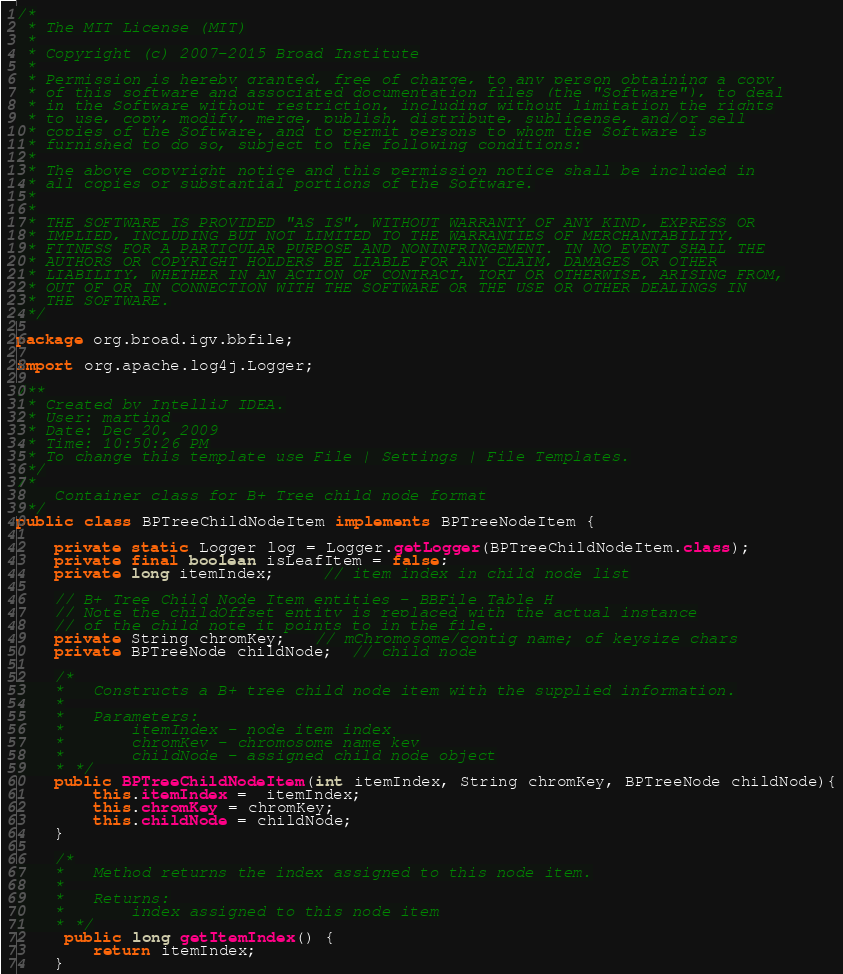Convert code to text. <code><loc_0><loc_0><loc_500><loc_500><_Java_>/*
 * The MIT License (MIT)
 *
 * Copyright (c) 2007-2015 Broad Institute
 *
 * Permission is hereby granted, free of charge, to any person obtaining a copy
 * of this software and associated documentation files (the "Software"), to deal
 * in the Software without restriction, including without limitation the rights
 * to use, copy, modify, merge, publish, distribute, sublicense, and/or sell
 * copies of the Software, and to permit persons to whom the Software is
 * furnished to do so, subject to the following conditions:
 *
 * The above copyright notice and this permission notice shall be included in
 * all copies or substantial portions of the Software.
 *
 *
 * THE SOFTWARE IS PROVIDED "AS IS", WITHOUT WARRANTY OF ANY KIND, EXPRESS OR
 * IMPLIED, INCLUDING BUT NOT LIMITED TO THE WARRANTIES OF MERCHANTABILITY,
 * FITNESS FOR A PARTICULAR PURPOSE AND NONINFRINGEMENT. IN NO EVENT SHALL THE
 * AUTHORS OR COPYRIGHT HOLDERS BE LIABLE FOR ANY CLAIM, DAMAGES OR OTHER
 * LIABILITY, WHETHER IN AN ACTION OF CONTRACT, TORT OR OTHERWISE, ARISING FROM,
 * OUT OF OR IN CONNECTION WITH THE SOFTWARE OR THE USE OR OTHER DEALINGS IN
 * THE SOFTWARE.
 */

package org.broad.igv.bbfile;

import org.apache.log4j.Logger;

/**
 * Created by IntelliJ IDEA.
 * User: martind
 * Date: Dec 20, 2009
 * Time: 10:50:26 PM
 * To change this template use File | Settings | File Templates.
 */
/*
    Container class for B+ Tree child node format
 */
public class BPTreeChildNodeItem implements BPTreeNodeItem {

    private static Logger log = Logger.getLogger(BPTreeChildNodeItem.class);
    private final boolean isLeafItem = false;
    private long itemIndex;     // item index in child node list

    // B+ Tree Child Node Item entities - BBFile Table H
    // Note the childOffset entity is replaced with the actual instance
    // of the child note it points to in the file.
    private String chromKey;   // mChromosome/contig name; of keysize chars
    private BPTreeNode childNode;  // child node

    /*
    *   Constructs a B+ tree child node item with the supplied information.
    *
    *   Parameters:
    *       itemIndex - node item index
    *       chromKey - chromosome name key
    *       childNode - assigned child node object
    * */
    public BPTreeChildNodeItem(int itemIndex, String chromKey, BPTreeNode childNode){
        this.itemIndex =  itemIndex;
        this.chromKey = chromKey;
        this.childNode = childNode;
    }

    /*
    *   Method returns the index assigned to this node item.
    *
    *   Returns:
    *       index assigned to this node item
    * */
     public long getItemIndex() {
        return itemIndex;
    }
</code> 